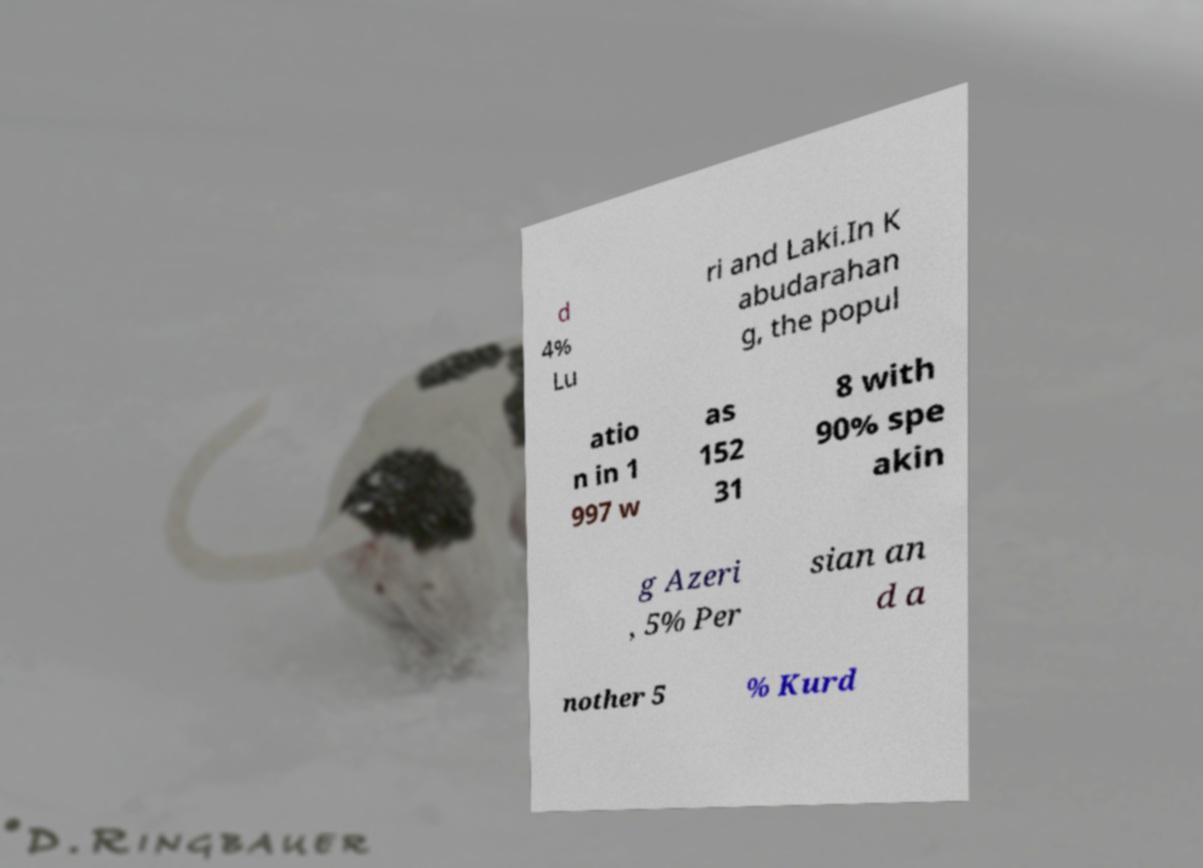Please read and relay the text visible in this image. What does it say? d 4% Lu ri and Laki.In K abudarahan g, the popul atio n in 1 997 w as 152 31 8 with 90% spe akin g Azeri , 5% Per sian an d a nother 5 % Kurd 